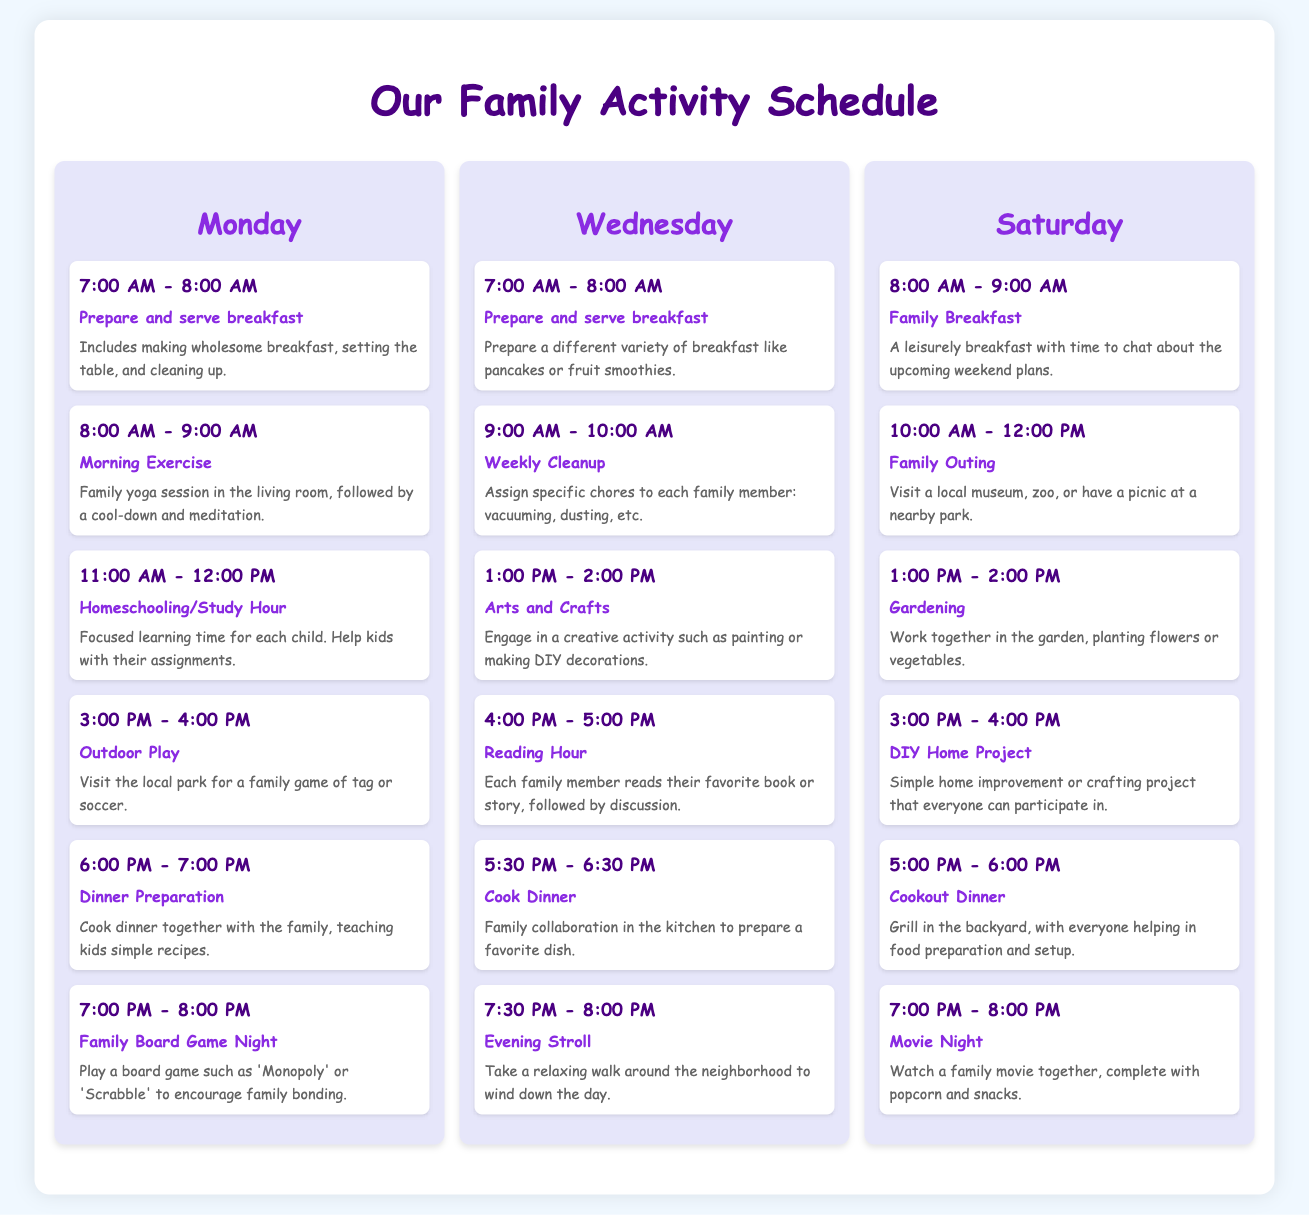What is the first task on Monday? The first task listed under Monday is "Prepare and serve breakfast".
Answer: Prepare and serve breakfast How long is the Tuesday morning exercise scheduled? The exercise session is scheduled from 8:00 AM to 9:00 AM, which is a duration of 1 hour.
Answer: 1 hour What activity is scheduled at 1:00 PM on Wednesday? The task scheduled at that time is "Arts and Crafts".
Answer: Arts and Crafts How many tasks are scheduled for Saturday? There are a total of 6 tasks listed on Saturday.
Answer: 6 tasks What kind of activity is planned for 5:00 PM on Saturday? The activity planned is a "Cookout Dinner".
Answer: Cookout Dinner Which day includes a "Family Board Game Night"? The task "Family Board Game Night" is scheduled for Monday.
Answer: Monday What is the main theme of the Wednesday tasks? The tasks on Wednesday primarily focus on family bonding and learning activities.
Answer: Bonding and learning activities What common task is repeated on both Monday and Wednesday? "Prepare and serve breakfast" appears in both Monday and Wednesday schedules.
Answer: Prepare and serve breakfast 